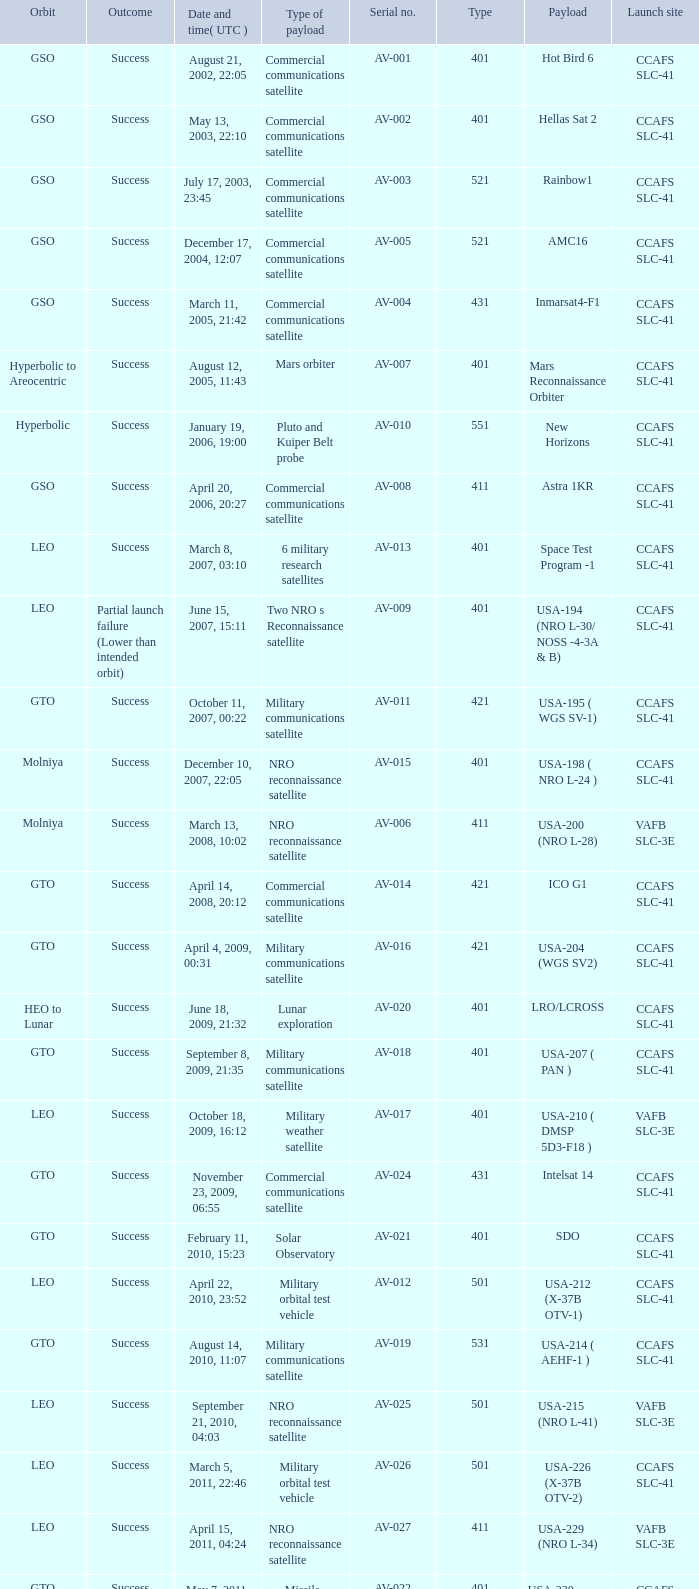For the payload of Van Allen Belts Exploration what's the serial number? AV-032. 